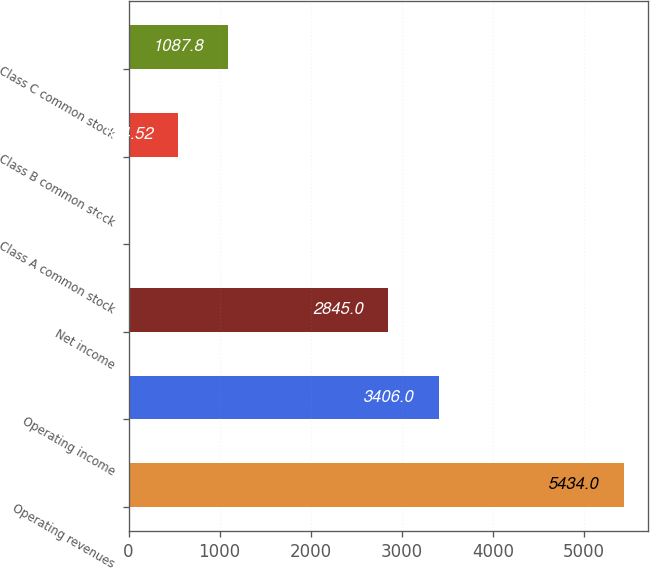Convert chart. <chart><loc_0><loc_0><loc_500><loc_500><bar_chart><fcel>Operating revenues<fcel>Operating income<fcel>Net income<fcel>Class A common stock<fcel>Class B common stock<fcel>Class C common stock<nl><fcel>5434<fcel>3406<fcel>2845<fcel>1.24<fcel>544.52<fcel>1087.8<nl></chart> 